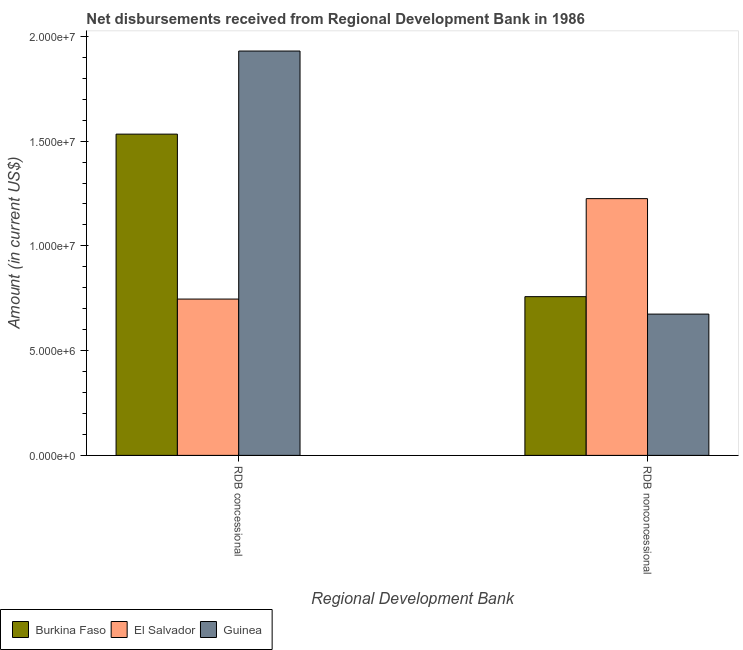How many different coloured bars are there?
Your answer should be very brief. 3. Are the number of bars on each tick of the X-axis equal?
Keep it short and to the point. Yes. What is the label of the 1st group of bars from the left?
Provide a succinct answer. RDB concessional. What is the net non concessional disbursements from rdb in Burkina Faso?
Keep it short and to the point. 7.58e+06. Across all countries, what is the maximum net concessional disbursements from rdb?
Offer a very short reply. 1.93e+07. Across all countries, what is the minimum net concessional disbursements from rdb?
Your answer should be compact. 7.46e+06. In which country was the net concessional disbursements from rdb maximum?
Provide a succinct answer. Guinea. In which country was the net concessional disbursements from rdb minimum?
Your answer should be compact. El Salvador. What is the total net concessional disbursements from rdb in the graph?
Keep it short and to the point. 4.21e+07. What is the difference between the net non concessional disbursements from rdb in Burkina Faso and that in El Salvador?
Provide a short and direct response. -4.68e+06. What is the difference between the net concessional disbursements from rdb in Guinea and the net non concessional disbursements from rdb in El Salvador?
Ensure brevity in your answer.  7.04e+06. What is the average net non concessional disbursements from rdb per country?
Provide a short and direct response. 8.86e+06. What is the difference between the net non concessional disbursements from rdb and net concessional disbursements from rdb in Burkina Faso?
Make the answer very short. -7.76e+06. What is the ratio of the net concessional disbursements from rdb in Burkina Faso to that in Guinea?
Make the answer very short. 0.79. Is the net concessional disbursements from rdb in Burkina Faso less than that in El Salvador?
Your response must be concise. No. In how many countries, is the net concessional disbursements from rdb greater than the average net concessional disbursements from rdb taken over all countries?
Your answer should be compact. 2. What does the 3rd bar from the left in RDB concessional represents?
Your answer should be compact. Guinea. What does the 2nd bar from the right in RDB concessional represents?
Make the answer very short. El Salvador. Are all the bars in the graph horizontal?
Offer a terse response. No. What is the difference between two consecutive major ticks on the Y-axis?
Provide a succinct answer. 5.00e+06. Are the values on the major ticks of Y-axis written in scientific E-notation?
Give a very brief answer. Yes. Does the graph contain any zero values?
Offer a very short reply. No. Does the graph contain grids?
Ensure brevity in your answer.  No. How many legend labels are there?
Provide a short and direct response. 3. What is the title of the graph?
Your answer should be very brief. Net disbursements received from Regional Development Bank in 1986. What is the label or title of the X-axis?
Provide a short and direct response. Regional Development Bank. What is the Amount (in current US$) in Burkina Faso in RDB concessional?
Provide a short and direct response. 1.53e+07. What is the Amount (in current US$) of El Salvador in RDB concessional?
Provide a short and direct response. 7.46e+06. What is the Amount (in current US$) of Guinea in RDB concessional?
Provide a short and direct response. 1.93e+07. What is the Amount (in current US$) in Burkina Faso in RDB nonconcessional?
Your answer should be very brief. 7.58e+06. What is the Amount (in current US$) in El Salvador in RDB nonconcessional?
Keep it short and to the point. 1.23e+07. What is the Amount (in current US$) in Guinea in RDB nonconcessional?
Offer a terse response. 6.74e+06. Across all Regional Development Bank, what is the maximum Amount (in current US$) of Burkina Faso?
Your answer should be compact. 1.53e+07. Across all Regional Development Bank, what is the maximum Amount (in current US$) in El Salvador?
Your answer should be very brief. 1.23e+07. Across all Regional Development Bank, what is the maximum Amount (in current US$) of Guinea?
Provide a short and direct response. 1.93e+07. Across all Regional Development Bank, what is the minimum Amount (in current US$) of Burkina Faso?
Your response must be concise. 7.58e+06. Across all Regional Development Bank, what is the minimum Amount (in current US$) of El Salvador?
Ensure brevity in your answer.  7.46e+06. Across all Regional Development Bank, what is the minimum Amount (in current US$) of Guinea?
Make the answer very short. 6.74e+06. What is the total Amount (in current US$) of Burkina Faso in the graph?
Your answer should be very brief. 2.29e+07. What is the total Amount (in current US$) in El Salvador in the graph?
Give a very brief answer. 1.97e+07. What is the total Amount (in current US$) in Guinea in the graph?
Your response must be concise. 2.60e+07. What is the difference between the Amount (in current US$) of Burkina Faso in RDB concessional and that in RDB nonconcessional?
Offer a very short reply. 7.76e+06. What is the difference between the Amount (in current US$) of El Salvador in RDB concessional and that in RDB nonconcessional?
Offer a very short reply. -4.79e+06. What is the difference between the Amount (in current US$) in Guinea in RDB concessional and that in RDB nonconcessional?
Give a very brief answer. 1.26e+07. What is the difference between the Amount (in current US$) in Burkina Faso in RDB concessional and the Amount (in current US$) in El Salvador in RDB nonconcessional?
Keep it short and to the point. 3.08e+06. What is the difference between the Amount (in current US$) of Burkina Faso in RDB concessional and the Amount (in current US$) of Guinea in RDB nonconcessional?
Provide a short and direct response. 8.59e+06. What is the difference between the Amount (in current US$) of El Salvador in RDB concessional and the Amount (in current US$) of Guinea in RDB nonconcessional?
Offer a very short reply. 7.17e+05. What is the average Amount (in current US$) of Burkina Faso per Regional Development Bank?
Your answer should be compact. 1.15e+07. What is the average Amount (in current US$) of El Salvador per Regional Development Bank?
Provide a short and direct response. 9.86e+06. What is the average Amount (in current US$) in Guinea per Regional Development Bank?
Keep it short and to the point. 1.30e+07. What is the difference between the Amount (in current US$) of Burkina Faso and Amount (in current US$) of El Salvador in RDB concessional?
Your answer should be compact. 7.87e+06. What is the difference between the Amount (in current US$) of Burkina Faso and Amount (in current US$) of Guinea in RDB concessional?
Provide a succinct answer. -3.97e+06. What is the difference between the Amount (in current US$) of El Salvador and Amount (in current US$) of Guinea in RDB concessional?
Ensure brevity in your answer.  -1.18e+07. What is the difference between the Amount (in current US$) of Burkina Faso and Amount (in current US$) of El Salvador in RDB nonconcessional?
Ensure brevity in your answer.  -4.68e+06. What is the difference between the Amount (in current US$) of Burkina Faso and Amount (in current US$) of Guinea in RDB nonconcessional?
Keep it short and to the point. 8.33e+05. What is the difference between the Amount (in current US$) in El Salvador and Amount (in current US$) in Guinea in RDB nonconcessional?
Offer a terse response. 5.51e+06. What is the ratio of the Amount (in current US$) of Burkina Faso in RDB concessional to that in RDB nonconcessional?
Make the answer very short. 2.02. What is the ratio of the Amount (in current US$) in El Salvador in RDB concessional to that in RDB nonconcessional?
Offer a very short reply. 0.61. What is the ratio of the Amount (in current US$) in Guinea in RDB concessional to that in RDB nonconcessional?
Offer a terse response. 2.86. What is the difference between the highest and the second highest Amount (in current US$) of Burkina Faso?
Keep it short and to the point. 7.76e+06. What is the difference between the highest and the second highest Amount (in current US$) in El Salvador?
Provide a succinct answer. 4.79e+06. What is the difference between the highest and the second highest Amount (in current US$) in Guinea?
Offer a very short reply. 1.26e+07. What is the difference between the highest and the lowest Amount (in current US$) of Burkina Faso?
Offer a very short reply. 7.76e+06. What is the difference between the highest and the lowest Amount (in current US$) in El Salvador?
Provide a succinct answer. 4.79e+06. What is the difference between the highest and the lowest Amount (in current US$) of Guinea?
Offer a very short reply. 1.26e+07. 